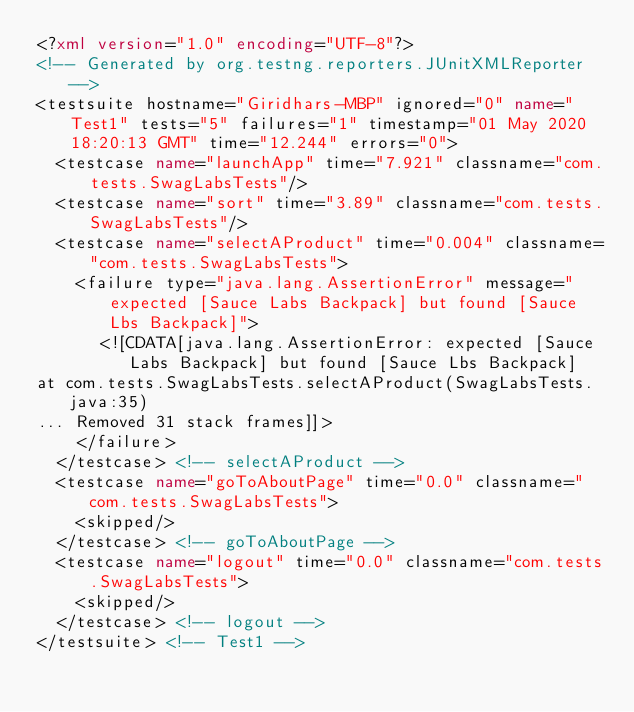Convert code to text. <code><loc_0><loc_0><loc_500><loc_500><_XML_><?xml version="1.0" encoding="UTF-8"?>
<!-- Generated by org.testng.reporters.JUnitXMLReporter -->
<testsuite hostname="Giridhars-MBP" ignored="0" name="Test1" tests="5" failures="1" timestamp="01 May 2020 18:20:13 GMT" time="12.244" errors="0">
  <testcase name="launchApp" time="7.921" classname="com.tests.SwagLabsTests"/>
  <testcase name="sort" time="3.89" classname="com.tests.SwagLabsTests"/>
  <testcase name="selectAProduct" time="0.004" classname="com.tests.SwagLabsTests">
    <failure type="java.lang.AssertionError" message="expected [Sauce Labs Backpack] but found [Sauce Lbs Backpack]">
      <![CDATA[java.lang.AssertionError: expected [Sauce Labs Backpack] but found [Sauce Lbs Backpack]
at com.tests.SwagLabsTests.selectAProduct(SwagLabsTests.java:35)
... Removed 31 stack frames]]>
    </failure>
  </testcase> <!-- selectAProduct -->
  <testcase name="goToAboutPage" time="0.0" classname="com.tests.SwagLabsTests">
    <skipped/>
  </testcase> <!-- goToAboutPage -->
  <testcase name="logout" time="0.0" classname="com.tests.SwagLabsTests">
    <skipped/>
  </testcase> <!-- logout -->
</testsuite> <!-- Test1 -->
</code> 